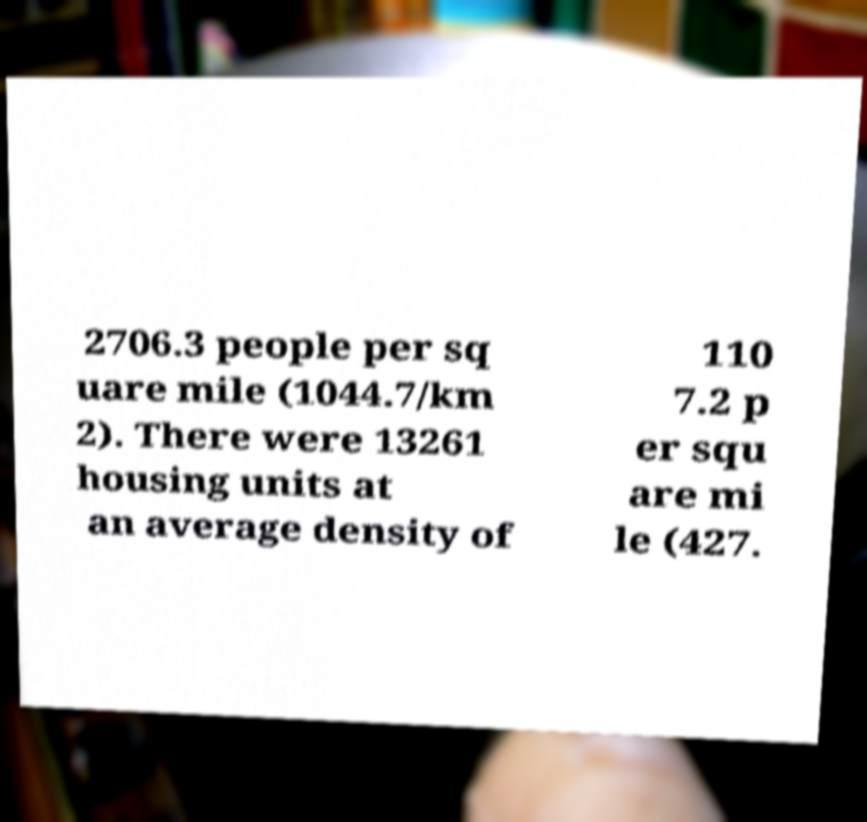I need the written content from this picture converted into text. Can you do that? 2706.3 people per sq uare mile (1044.7/km 2). There were 13261 housing units at an average density of 110 7.2 p er squ are mi le (427. 